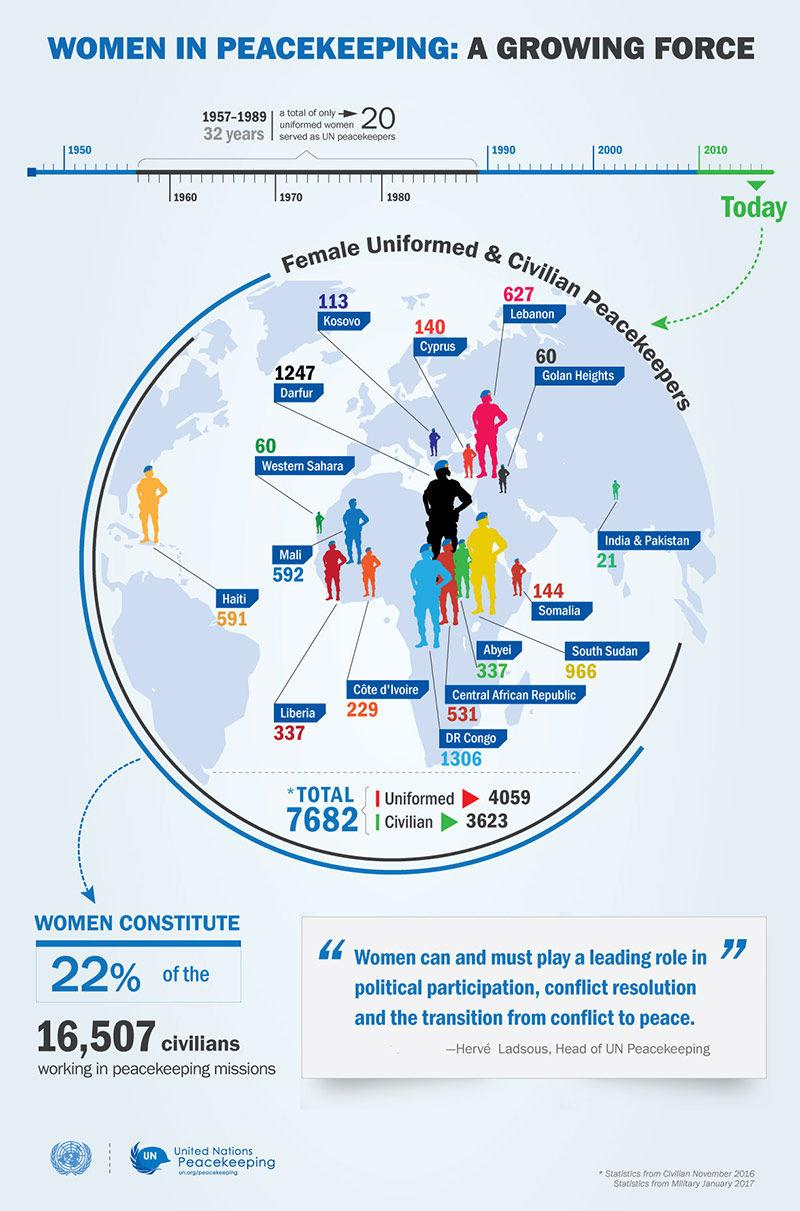Give some essential details in this illustration. In 2016, a total of 627 un There were 21 female civilians who served as UN peacekeepers in India and Pakistan in 2016. In 2016, 60 female civilians served as United Nations peacekeepers in Western Sahara. During the time period of 1957-1989, approximately 20% of United Nations peacekeepers were female, despite their being less than 1% of the global military forces during that time. According to statistics, only 22% of the civilian workers in UN peacekeeping missions are women. 